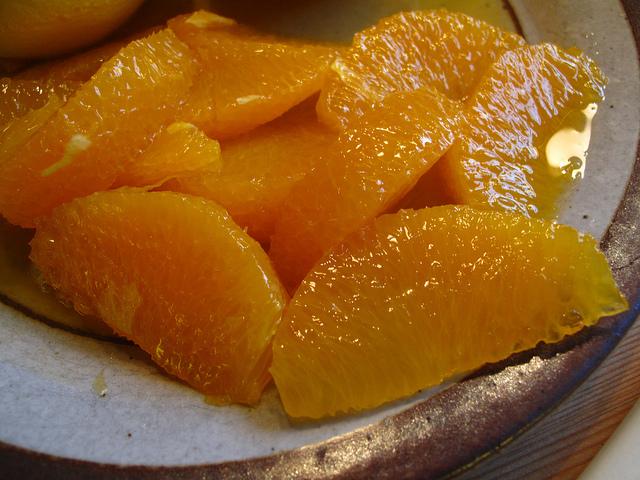How many different colors is the food?
Be succinct. 1. Are there any potatoes here?
Be succinct. No. Were these fresh or canned?
Concise answer only. Canned. What kind of food is this?
Give a very brief answer. Orange. What is being cooked?
Give a very brief answer. Oranges. Is this orange peeled too close to the skin?
Concise answer only. No. Is the fruit juicy?
Be succinct. Yes. Are all the fruit the same?
Quick response, please. Yes. Is this food fully cooked?
Give a very brief answer. No. 